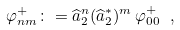Convert formula to latex. <formula><loc_0><loc_0><loc_500><loc_500>\varphi ^ { + } _ { n m } \colon = \widehat { a } _ { 2 } ^ { n } ( \widehat { a } _ { 2 } ^ { * } ) ^ { m } \, \varphi ^ { + } _ { 0 0 } \ ,</formula> 